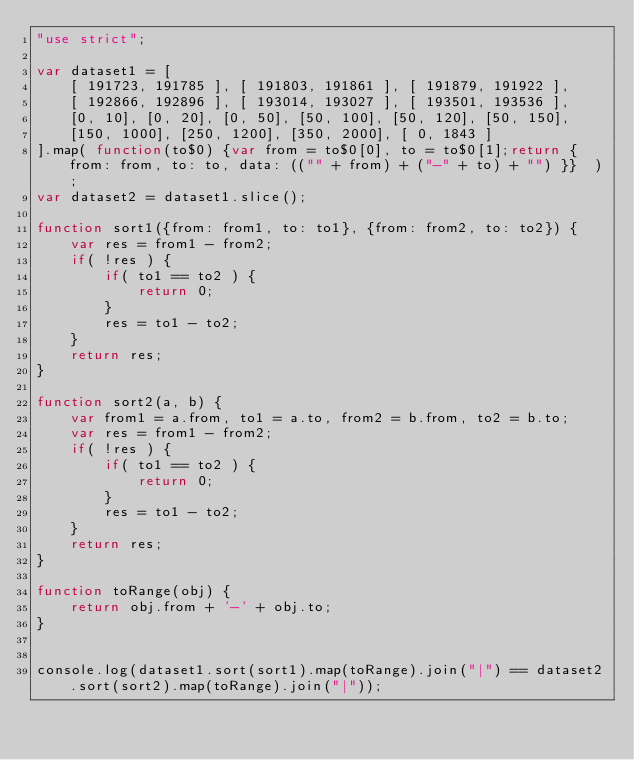Convert code to text. <code><loc_0><loc_0><loc_500><loc_500><_JavaScript_>"use strict";

var dataset1 = [
	[ 191723, 191785 ], [ 191803, 191861 ], [ 191879, 191922 ],
	[ 192866, 192896 ], [ 193014, 193027 ], [ 193501, 193536 ],
	[0, 10], [0, 20], [0, 50], [50, 100], [50, 120], [50, 150],
	[150, 1000], [250, 1200], [350, 2000], [ 0, 1843 ]
].map( function(to$0) {var from = to$0[0], to = to$0[1];return { from: from, to: to, data: (("" + from) + ("-" + to) + "") }}  );
var dataset2 = dataset1.slice();

function sort1({from: from1, to: to1}, {from: from2, to: to2}) {
	var res = from1 - from2;
	if( !res ) {
		if( to1 == to2 ) {
			return 0;
		}
		res = to1 - to2;
	}
	return res;
}

function sort2(a, b) {
	var from1 = a.from, to1 = a.to, from2 = b.from, to2 = b.to;
	var res = from1 - from2;
	if( !res ) {
		if( to1 == to2 ) {
			return 0;
		}
		res = to1 - to2;
	}
	return res;
}

function toRange(obj) {
	return obj.from + '-' + obj.to;
}


console.log(dataset1.sort(sort1).map(toRange).join("|") == dataset2.sort(sort2).map(toRange).join("|"));</code> 